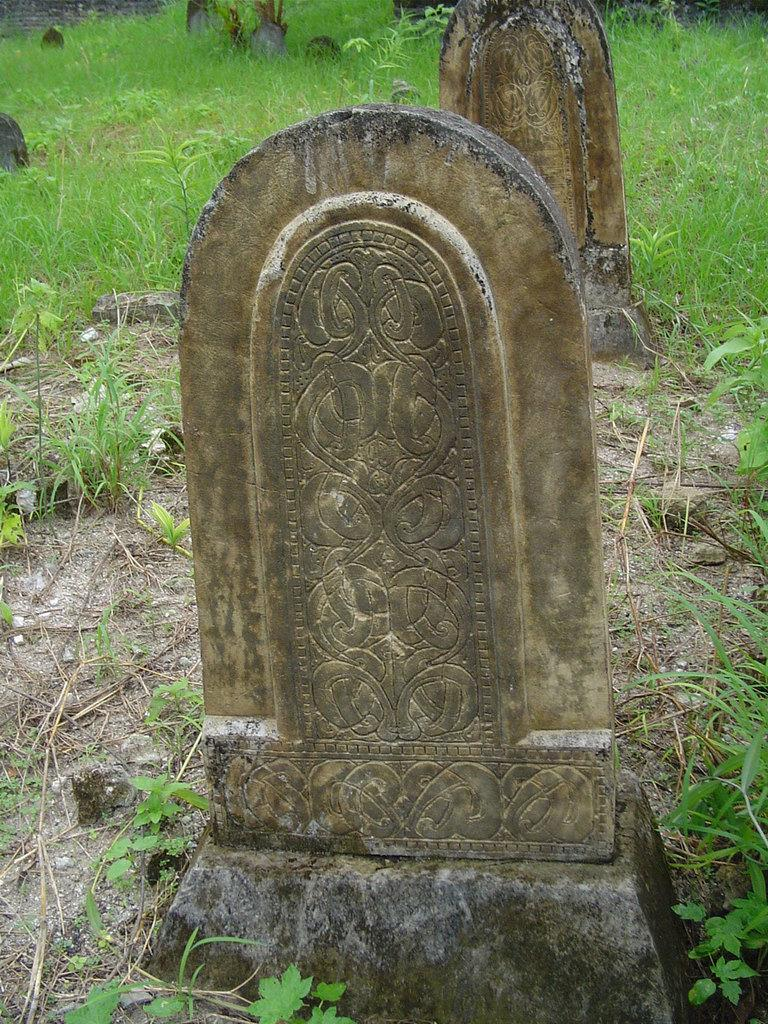What is the main subject of the image? The main subject of the image is two headstones in the center. What can be observed on the headstones? The headstones have some design on them. What is visible in the background of the image? There is a wall and grass in the background of the image. Are there any other headstones in the image? Yes, there are other headstones in the background of the image. What type of toys can be seen scattered around the headstones in the image? There are no toys present in the image; it features headstones in a cemetery. Can you tell me how many dolls are sitting on the headstones in the image? There are no dolls present in the image; it features headstones in a cemetery. 